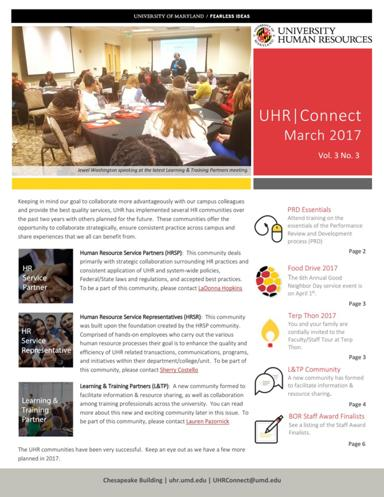What is the main topic of the text in the image? The primary subject of the text in the image is the University Human Resources (UHR) Connect newsletter from March 2017. This publication serves as a means to keep the university staff updated on pertinent HR news and events. 